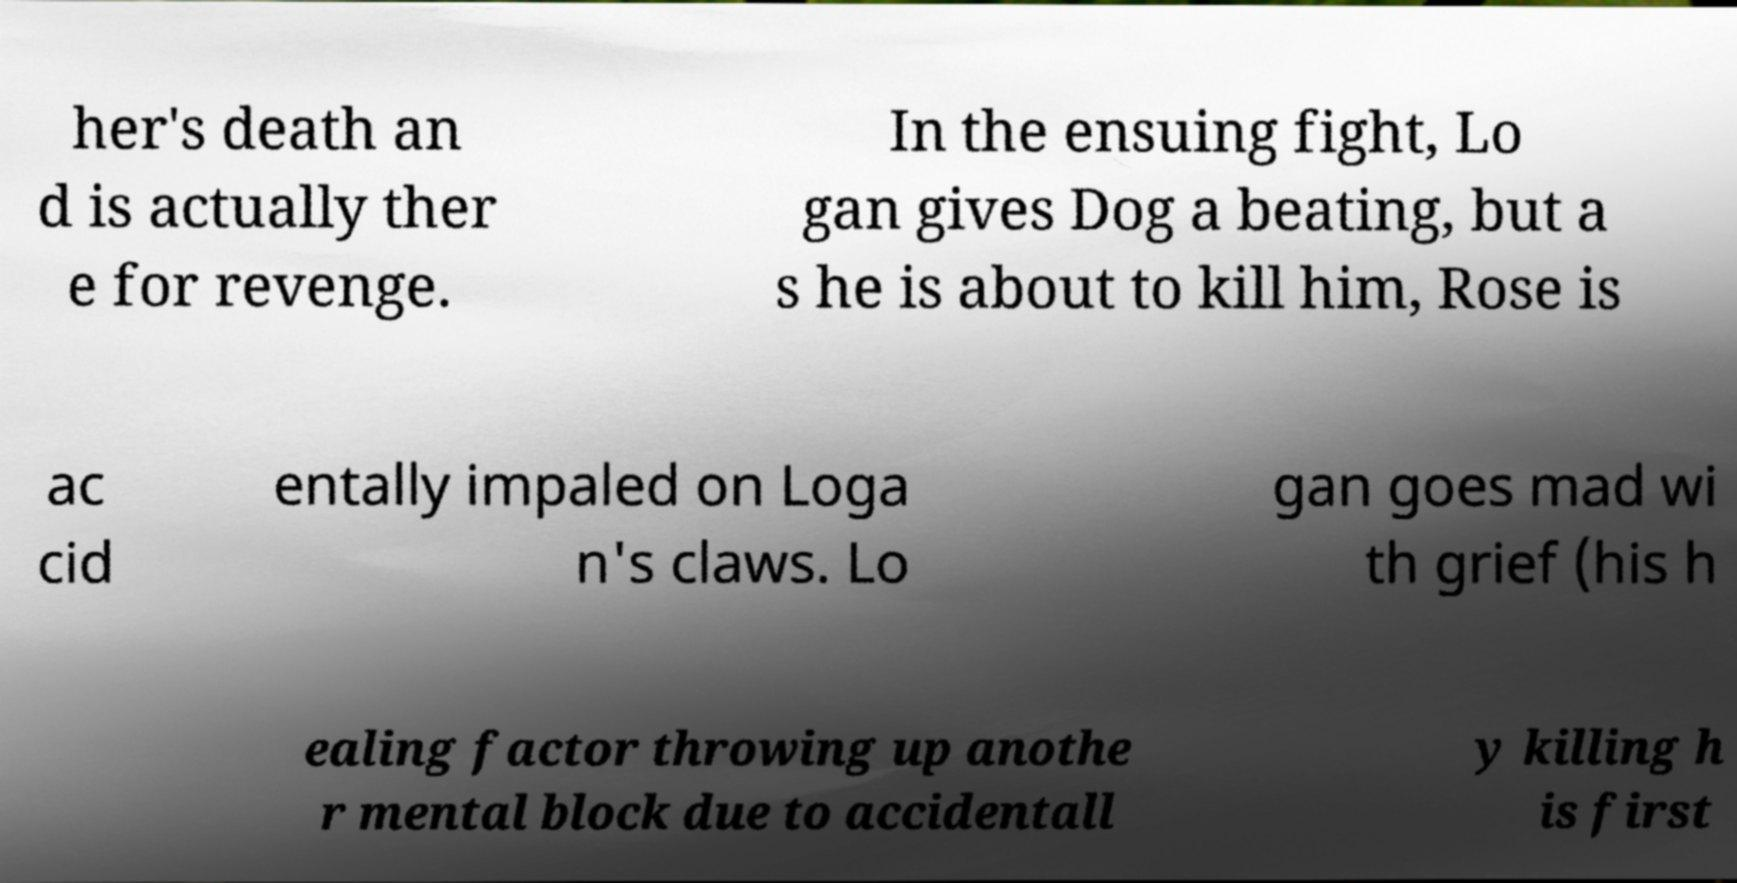Please read and relay the text visible in this image. What does it say? her's death an d is actually ther e for revenge. In the ensuing fight, Lo gan gives Dog a beating, but a s he is about to kill him, Rose is ac cid entally impaled on Loga n's claws. Lo gan goes mad wi th grief (his h ealing factor throwing up anothe r mental block due to accidentall y killing h is first 